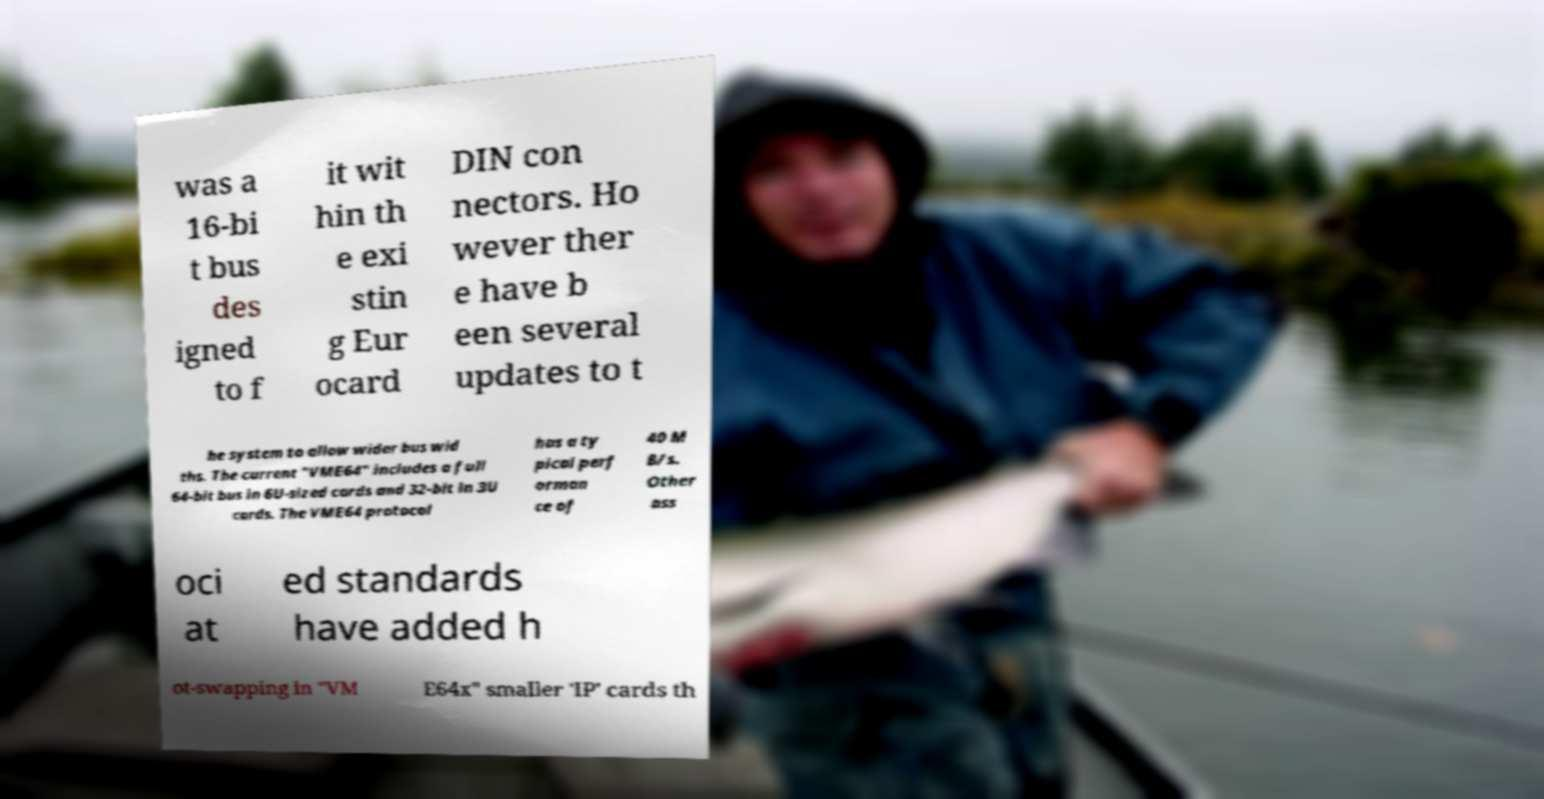There's text embedded in this image that I need extracted. Can you transcribe it verbatim? was a 16-bi t bus des igned to f it wit hin th e exi stin g Eur ocard DIN con nectors. Ho wever ther e have b een several updates to t he system to allow wider bus wid ths. The current "VME64" includes a full 64-bit bus in 6U-sized cards and 32-bit in 3U cards. The VME64 protocol has a ty pical perf orman ce of 40 M B/s. Other ass oci at ed standards have added h ot-swapping in "VM E64x" smaller 'IP' cards th 